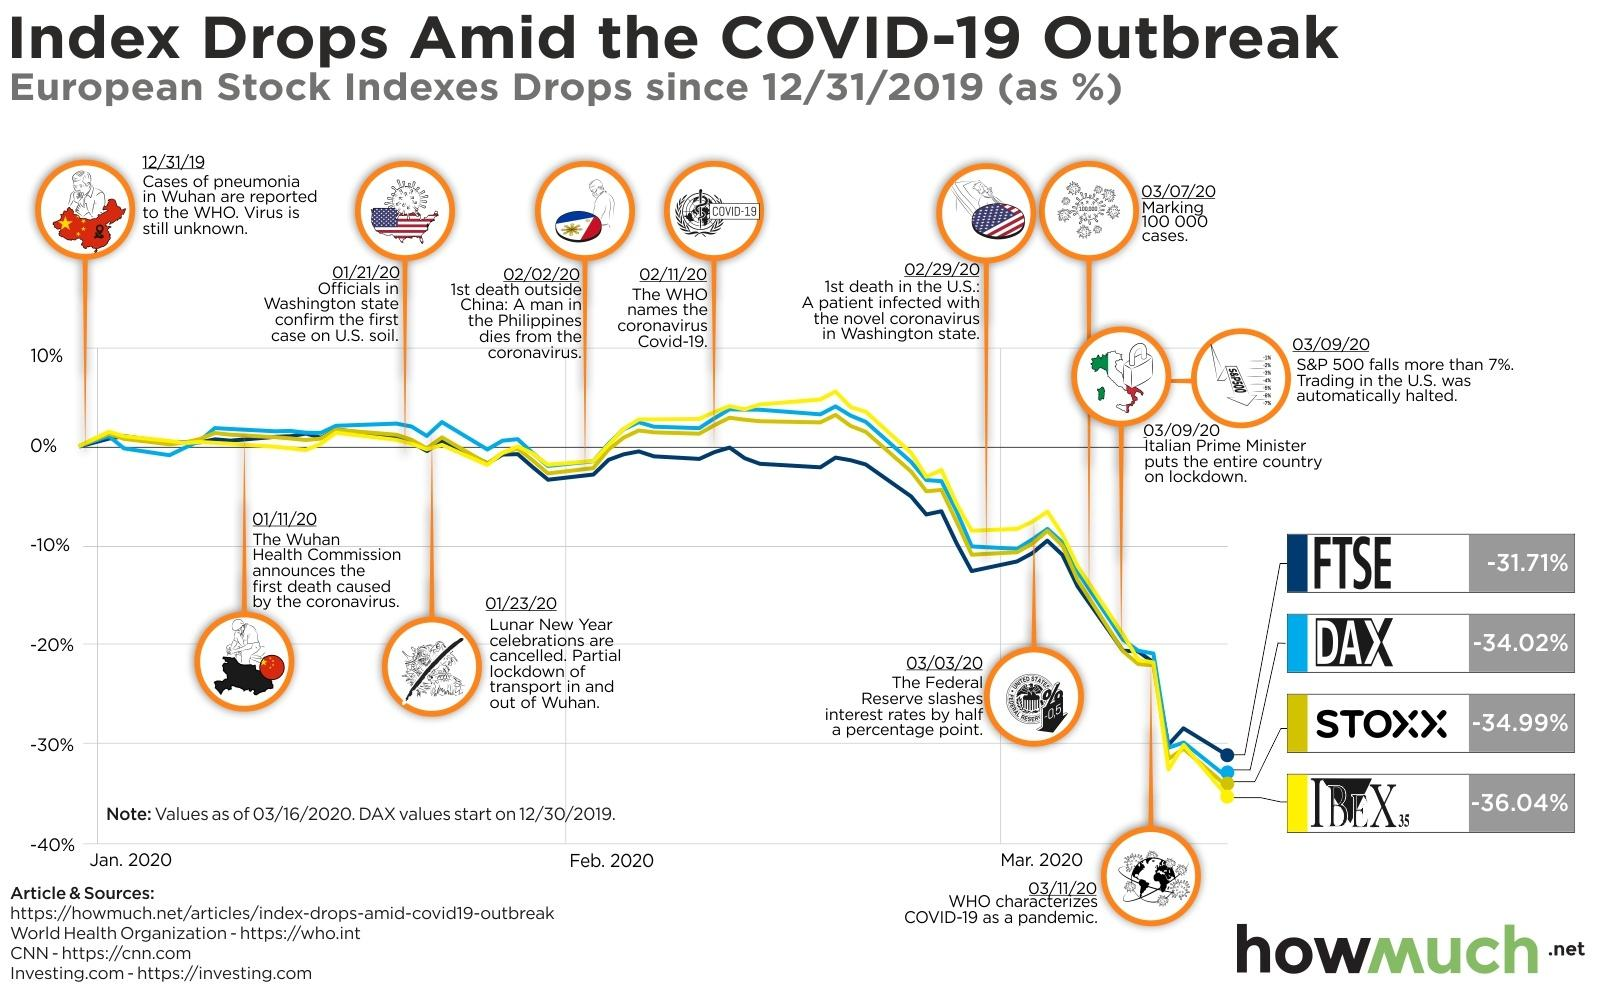Give some essential details in this illustration. The first death outside of China due to the coronavirus occurred on February 2, 2023. On February 11th, the World Health Organization (WHO) officially named the novel coronavirus as "Covid-19. The green line represents STOXX, which is a financial index that tracks the performance of companies in the technology, media, telecommunications, and energy sectors. On September 3rd, 2021, Italy was placed under lockdown. The yellow line represents IBEX, which is a spacecraft that was launched to study the interaction between the solar wind and the interstellar medium. 